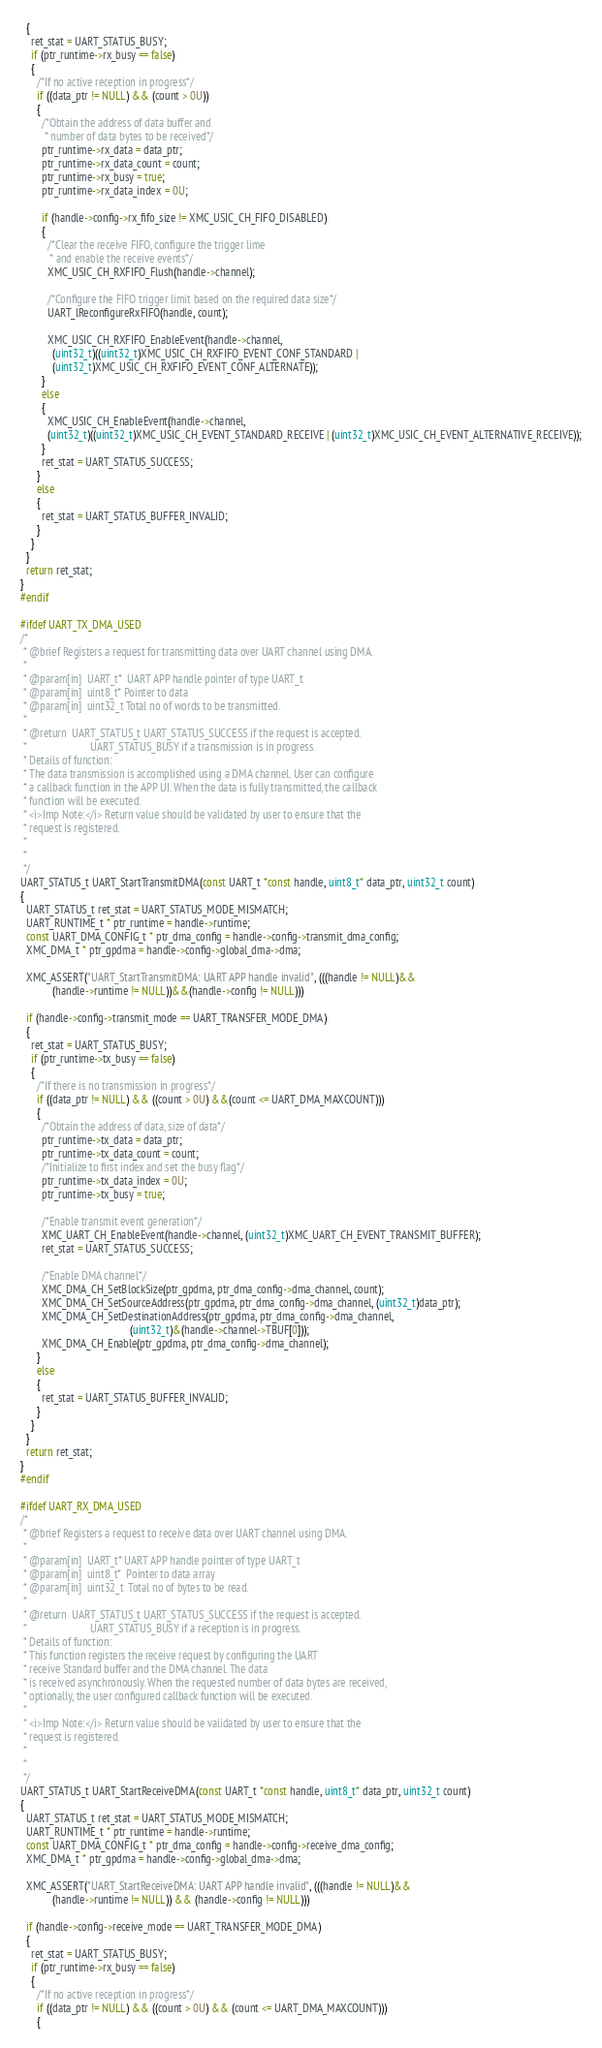Convert code to text. <code><loc_0><loc_0><loc_500><loc_500><_C_>  {
    ret_stat = UART_STATUS_BUSY;
    if (ptr_runtime->rx_busy == false)
    {
      /*If no active reception in progress*/
      if ((data_ptr != NULL) && (count > 0U))
      {
        /*Obtain the address of data buffer and
         * number of data bytes to be received*/
        ptr_runtime->rx_data = data_ptr;
        ptr_runtime->rx_data_count = count;
        ptr_runtime->rx_busy = true;
        ptr_runtime->rx_data_index = 0U;

        if (handle->config->rx_fifo_size != XMC_USIC_CH_FIFO_DISABLED)
        {
          /*Clear the receive FIFO, configure the trigger lime
           * and enable the receive events*/
          XMC_USIC_CH_RXFIFO_Flush(handle->channel);

          /*Configure the FIFO trigger limit based on the required data size*/
          UART_lReconfigureRxFIFO(handle, count);

          XMC_USIC_CH_RXFIFO_EnableEvent(handle->channel,
            (uint32_t)((uint32_t)XMC_USIC_CH_RXFIFO_EVENT_CONF_STANDARD |
            (uint32_t)XMC_USIC_CH_RXFIFO_EVENT_CONF_ALTERNATE));
        }
        else
        {
          XMC_USIC_CH_EnableEvent(handle->channel,
          (uint32_t)((uint32_t)XMC_USIC_CH_EVENT_STANDARD_RECEIVE | (uint32_t)XMC_USIC_CH_EVENT_ALTERNATIVE_RECEIVE));
        }
        ret_stat = UART_STATUS_SUCCESS;
      }
      else
      {
        ret_stat = UART_STATUS_BUFFER_INVALID;
      }
    }
  }
  return ret_stat;
}
#endif

#ifdef UART_TX_DMA_USED
/*
 * @brief Registers a request for transmitting data over UART channel using DMA.
 *
 * @param[in]  UART_t*  UART APP handle pointer of type UART_t
 * @param[in]  uint8_t* Pointer to data
 * @param[in]  uint32_t Total no of words to be transmitted.
 *
 * @return  UART_STATUS_t UART_STATUS_SUCCESS if the request is accepted.
 *                        UART_STATUS_BUSY if a transmission is in progress.
 * Details of function:
 * The data transmission is accomplished using a DMA channel. User can configure
 * a callback function in the APP UI. When the data is fully transmitted, the callback
 * function will be executed.
 * <i>Imp Note:</i> Return value should be validated by user to ensure that the
 * request is registered.
 *
 *
 */
UART_STATUS_t UART_StartTransmitDMA(const UART_t *const handle, uint8_t* data_ptr, uint32_t count)
{
  UART_STATUS_t ret_stat = UART_STATUS_MODE_MISMATCH;
  UART_RUNTIME_t * ptr_runtime = handle->runtime;
  const UART_DMA_CONFIG_t * ptr_dma_config = handle->config->transmit_dma_config;
  XMC_DMA_t * ptr_gpdma = handle->config->global_dma->dma;

  XMC_ASSERT("UART_StartTransmitDMA: UART APP handle invalid", (((handle != NULL)&&
            (handle->runtime != NULL))&&(handle->config != NULL)))

  if (handle->config->transmit_mode == UART_TRANSFER_MODE_DMA)
  {
    ret_stat = UART_STATUS_BUSY;
    if (ptr_runtime->tx_busy == false)
    {
      /*If there is no transmission in progress*/
      if ((data_ptr != NULL) && ((count > 0U) &&(count <= UART_DMA_MAXCOUNT)))
      {
        /*Obtain the address of data, size of data*/
        ptr_runtime->tx_data = data_ptr;
        ptr_runtime->tx_data_count = count;
        /*Initialize to first index and set the busy flag*/
        ptr_runtime->tx_data_index = 0U;
        ptr_runtime->tx_busy = true;

        /*Enable transmit event generation*/
        XMC_UART_CH_EnableEvent(handle->channel, (uint32_t)XMC_UART_CH_EVENT_TRANSMIT_BUFFER);
        ret_stat = UART_STATUS_SUCCESS;

        /*Enable DMA channel*/
        XMC_DMA_CH_SetBlockSize(ptr_gpdma, ptr_dma_config->dma_channel, count);
        XMC_DMA_CH_SetSourceAddress(ptr_gpdma, ptr_dma_config->dma_channel, (uint32_t)data_ptr);
        XMC_DMA_CH_SetDestinationAddress(ptr_gpdma, ptr_dma_config->dma_channel,
                                         (uint32_t)&(handle->channel->TBUF[0]));
        XMC_DMA_CH_Enable(ptr_gpdma, ptr_dma_config->dma_channel);
      }
      else
      {
        ret_stat = UART_STATUS_BUFFER_INVALID;
      }
    }
  }
  return ret_stat;
}
#endif

#ifdef UART_RX_DMA_USED
/*
 * @brief Registers a request to receive data over UART channel using DMA.
 *
 * @param[in]  UART_t* UART APP handle pointer of type UART_t
 * @param[in]  uint8_t*  Pointer to data array
 * @param[in]  uint32_t  Total no of bytes to be read.
 *
 * @return  UART_STATUS_t UART_STATUS_SUCCESS if the request is accepted.
 *                        UART_STATUS_BUSY if a reception is in progress.
 * Details of function:
 * This function registers the receive request by configuring the UART
 * receive Standard buffer and the DMA channel. The data
 * is received asynchronously. When the requested number of data bytes are received,
 * optionally, the user configured callback function will be executed.
 *
 * <i>Imp Note:</i> Return value should be validated by user to ensure that the
 * request is registered.
 *
 *
 */
UART_STATUS_t UART_StartReceiveDMA(const UART_t *const handle, uint8_t* data_ptr, uint32_t count)
{
  UART_STATUS_t ret_stat = UART_STATUS_MODE_MISMATCH;
  UART_RUNTIME_t * ptr_runtime = handle->runtime;
  const UART_DMA_CONFIG_t * ptr_dma_config = handle->config->receive_dma_config;
  XMC_DMA_t * ptr_gpdma = handle->config->global_dma->dma;

  XMC_ASSERT("UART_StartReceiveDMA: UART APP handle invalid", (((handle != NULL)&&
            (handle->runtime != NULL)) && (handle->config != NULL)))

  if (handle->config->receive_mode == UART_TRANSFER_MODE_DMA)
  {
    ret_stat = UART_STATUS_BUSY;
    if (ptr_runtime->rx_busy == false)
    {
      /*If no active reception in progress*/
      if ((data_ptr != NULL) && ((count > 0U) && (count <= UART_DMA_MAXCOUNT)))
      {</code> 